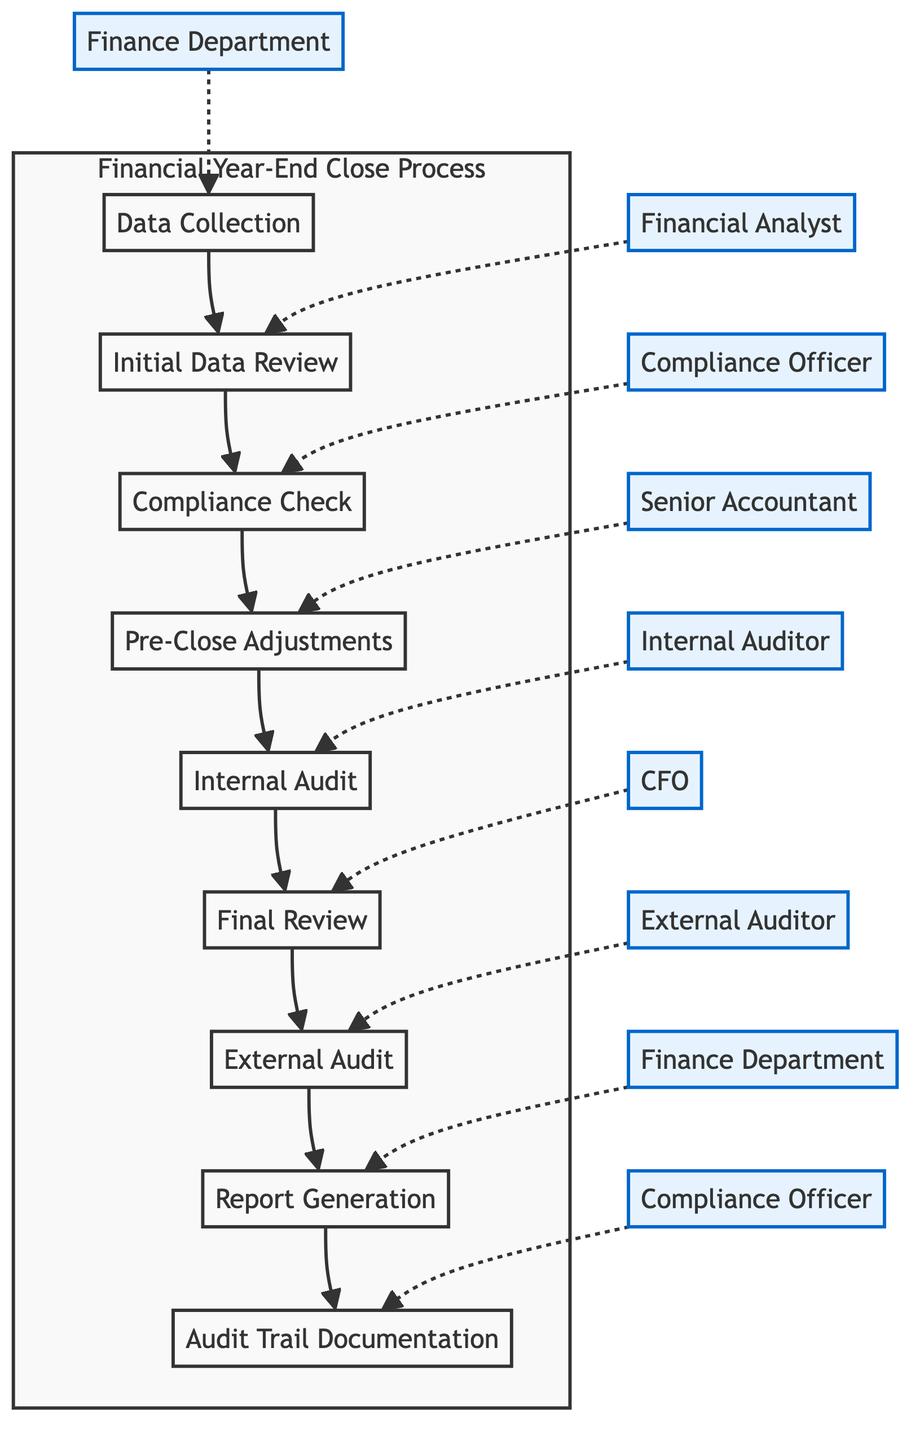What is the first step in the Financial Year-End Close Process? The first step as per the flowchart is "Data Collection", which is the initial action taken in the process.
Answer: Data Collection Who is responsible for conducting the Compliance Check? According to the diagram, the Compliance Officer is assigned the responsibility for the Compliance Check.
Answer: Compliance Officer How many main steps are outlined in the process? By counting the nodes in the diagram, there are a total of nine main steps listed in the Financial Year-End Close Process.
Answer: Nine What step follows the Internal Audit? In the flowchart, "Final Review" is the step that follows after the Internal Audit, indicating the sequence of actions.
Answer: Final Review Which role is responsible for the Report Generation? The role indicated in the diagram responsible for Report Generation is the Finance Department, as visually linked to that step.
Answer: Finance Department What action is taken during the Pre-Close Adjustments? The action taken during Pre-Close Adjustments includes creating adjusting journal entries, as per the description provided in the flowchart.
Answer: Create adjusting journal entries What comes after the Compliance Check in the process? After the Compliance Check, the next step in the process according to the diagram is Pre-Close Adjustments, showing the logical flow between these actions.
Answer: Pre-Close Adjustments Which step involves external auditors? The step involving external auditors is "External Audit," which specifically mentions engaging external auditors to certify financial statements.
Answer: External Audit What is maintained during the Audit Trail Documentation? During Audit Trail Documentation, detailed records of all compliance check activities are maintained, ensuring thorough documentation as shown in the flowchart.
Answer: Detailed records of compliance check activities 